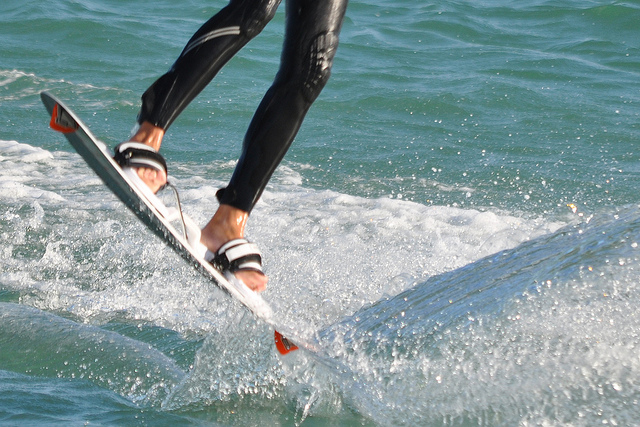What kind of activity is the person engaging in? The person seems to be involved in a water sport, possibly wakeboarding or water skiing, given they are riding over the waves on a board. Do they look experienced? From their posture and the control they have over the board, it seems like they have a good deal of experience in this sport. 